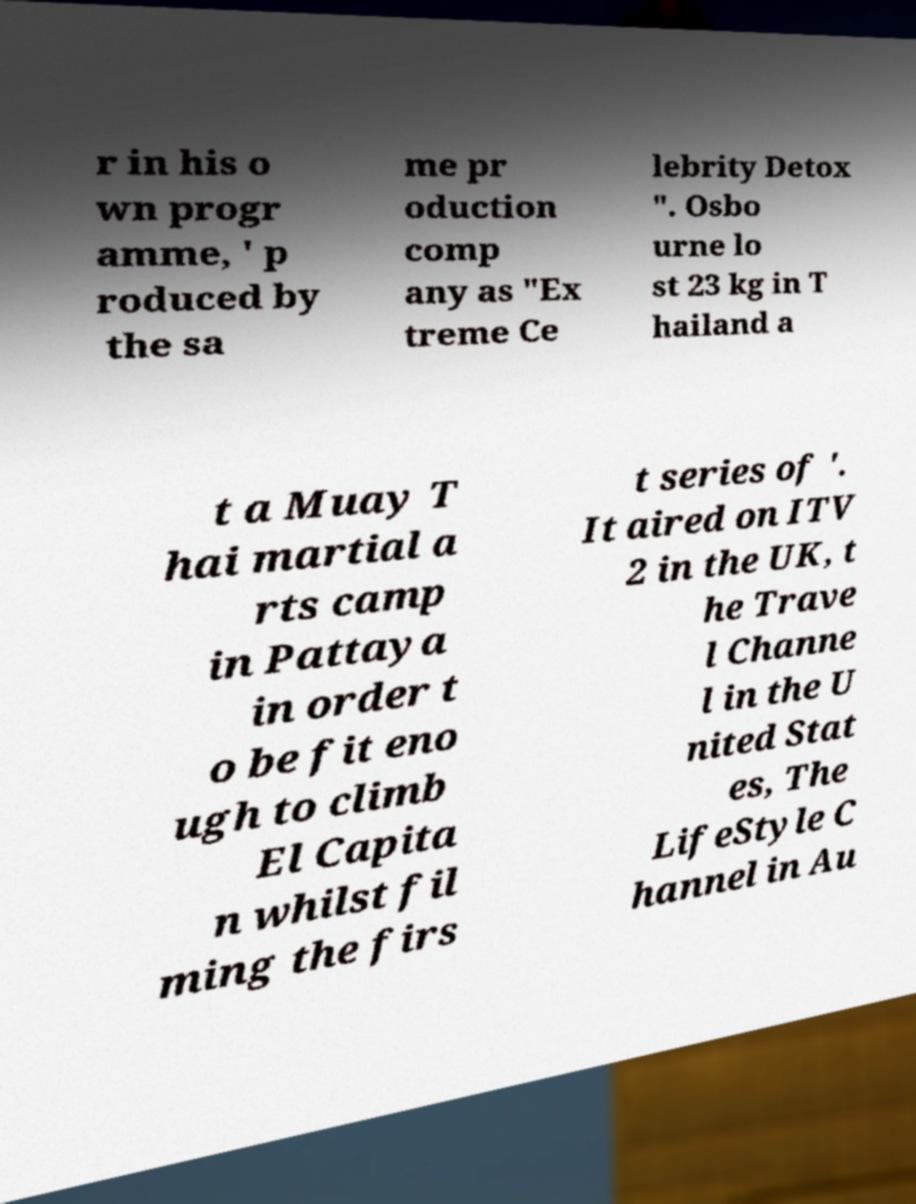I need the written content from this picture converted into text. Can you do that? r in his o wn progr amme, ' p roduced by the sa me pr oduction comp any as "Ex treme Ce lebrity Detox ". Osbo urne lo st 23 kg in T hailand a t a Muay T hai martial a rts camp in Pattaya in order t o be fit eno ugh to climb El Capita n whilst fil ming the firs t series of '. It aired on ITV 2 in the UK, t he Trave l Channe l in the U nited Stat es, The LifeStyle C hannel in Au 